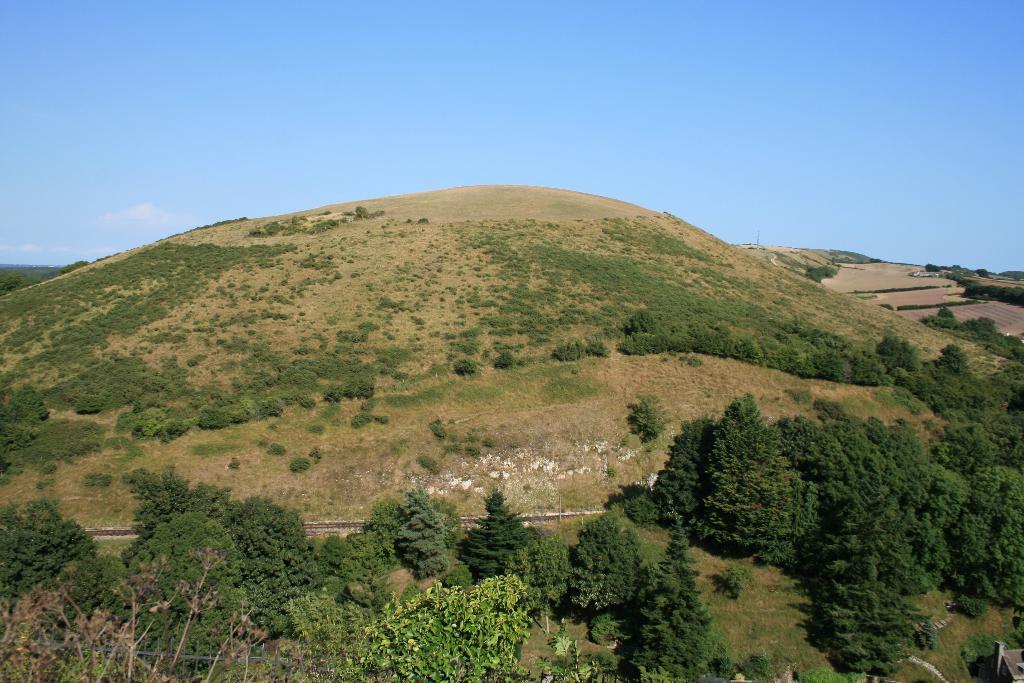Describe this image in one or two sentences. In this picture there is greenery in the center of the image. 